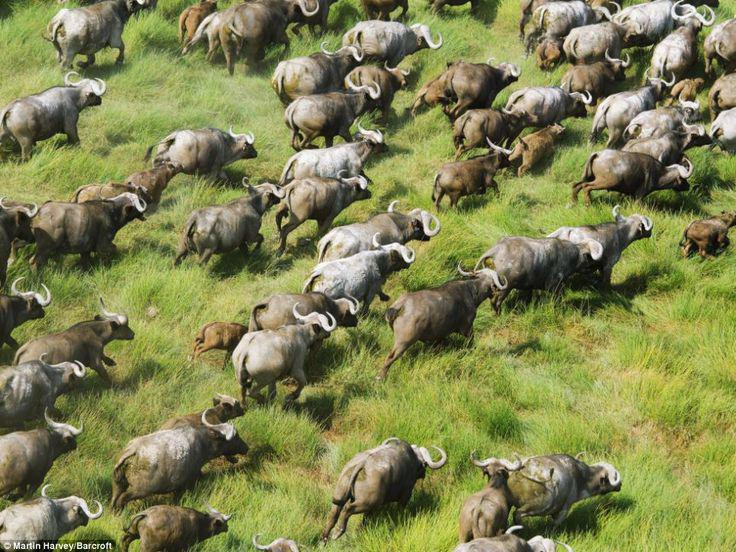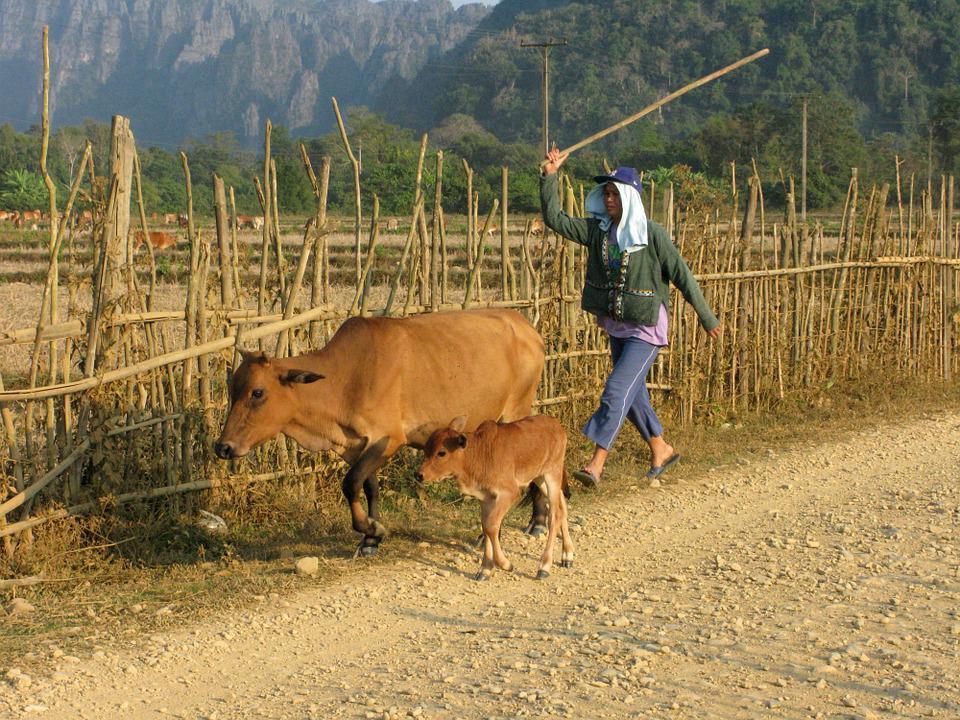The first image is the image on the left, the second image is the image on the right. Given the left and right images, does the statement "All images show water buffalo in the water, and one image shows at least one young male in the scene with water buffalo." hold true? Answer yes or no. No. 